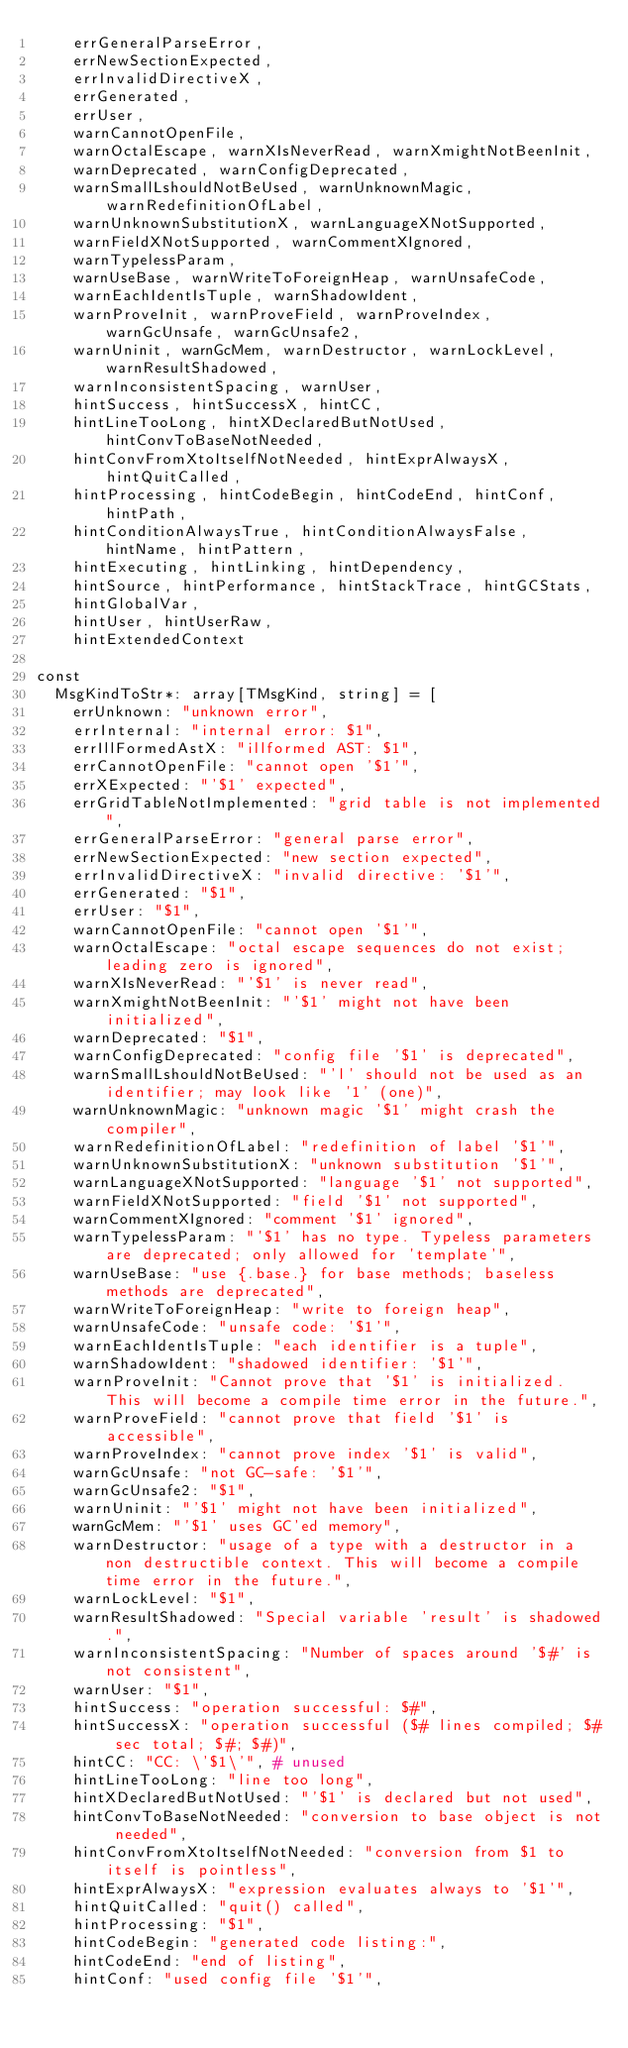Convert code to text. <code><loc_0><loc_0><loc_500><loc_500><_Nim_>    errGeneralParseError,
    errNewSectionExpected,
    errInvalidDirectiveX,
    errGenerated,
    errUser,
    warnCannotOpenFile,
    warnOctalEscape, warnXIsNeverRead, warnXmightNotBeenInit,
    warnDeprecated, warnConfigDeprecated,
    warnSmallLshouldNotBeUsed, warnUnknownMagic, warnRedefinitionOfLabel,
    warnUnknownSubstitutionX, warnLanguageXNotSupported,
    warnFieldXNotSupported, warnCommentXIgnored,
    warnTypelessParam,
    warnUseBase, warnWriteToForeignHeap, warnUnsafeCode,
    warnEachIdentIsTuple, warnShadowIdent,
    warnProveInit, warnProveField, warnProveIndex, warnGcUnsafe, warnGcUnsafe2,
    warnUninit, warnGcMem, warnDestructor, warnLockLevel, warnResultShadowed,
    warnInconsistentSpacing, warnUser,
    hintSuccess, hintSuccessX, hintCC,
    hintLineTooLong, hintXDeclaredButNotUsed, hintConvToBaseNotNeeded,
    hintConvFromXtoItselfNotNeeded, hintExprAlwaysX, hintQuitCalled,
    hintProcessing, hintCodeBegin, hintCodeEnd, hintConf, hintPath,
    hintConditionAlwaysTrue, hintConditionAlwaysFalse, hintName, hintPattern,
    hintExecuting, hintLinking, hintDependency,
    hintSource, hintPerformance, hintStackTrace, hintGCStats,
    hintGlobalVar,
    hintUser, hintUserRaw,
    hintExtendedContext

const
  MsgKindToStr*: array[TMsgKind, string] = [
    errUnknown: "unknown error",
    errInternal: "internal error: $1",
    errIllFormedAstX: "illformed AST: $1",
    errCannotOpenFile: "cannot open '$1'",
    errXExpected: "'$1' expected",
    errGridTableNotImplemented: "grid table is not implemented",
    errGeneralParseError: "general parse error",
    errNewSectionExpected: "new section expected",
    errInvalidDirectiveX: "invalid directive: '$1'",
    errGenerated: "$1",
    errUser: "$1",
    warnCannotOpenFile: "cannot open '$1'",
    warnOctalEscape: "octal escape sequences do not exist; leading zero is ignored",
    warnXIsNeverRead: "'$1' is never read",
    warnXmightNotBeenInit: "'$1' might not have been initialized",
    warnDeprecated: "$1",
    warnConfigDeprecated: "config file '$1' is deprecated",
    warnSmallLshouldNotBeUsed: "'l' should not be used as an identifier; may look like '1' (one)",
    warnUnknownMagic: "unknown magic '$1' might crash the compiler",
    warnRedefinitionOfLabel: "redefinition of label '$1'",
    warnUnknownSubstitutionX: "unknown substitution '$1'",
    warnLanguageXNotSupported: "language '$1' not supported",
    warnFieldXNotSupported: "field '$1' not supported",
    warnCommentXIgnored: "comment '$1' ignored",
    warnTypelessParam: "'$1' has no type. Typeless parameters are deprecated; only allowed for 'template'",
    warnUseBase: "use {.base.} for base methods; baseless methods are deprecated",
    warnWriteToForeignHeap: "write to foreign heap",
    warnUnsafeCode: "unsafe code: '$1'",
    warnEachIdentIsTuple: "each identifier is a tuple",
    warnShadowIdent: "shadowed identifier: '$1'",
    warnProveInit: "Cannot prove that '$1' is initialized. This will become a compile time error in the future.",
    warnProveField: "cannot prove that field '$1' is accessible",
    warnProveIndex: "cannot prove index '$1' is valid",
    warnGcUnsafe: "not GC-safe: '$1'",
    warnGcUnsafe2: "$1",
    warnUninit: "'$1' might not have been initialized",
    warnGcMem: "'$1' uses GC'ed memory",
    warnDestructor: "usage of a type with a destructor in a non destructible context. This will become a compile time error in the future.",
    warnLockLevel: "$1",
    warnResultShadowed: "Special variable 'result' is shadowed.",
    warnInconsistentSpacing: "Number of spaces around '$#' is not consistent",
    warnUser: "$1",
    hintSuccess: "operation successful: $#",
    hintSuccessX: "operation successful ($# lines compiled; $# sec total; $#; $#)",
    hintCC: "CC: \'$1\'", # unused
    hintLineTooLong: "line too long",
    hintXDeclaredButNotUsed: "'$1' is declared but not used",
    hintConvToBaseNotNeeded: "conversion to base object is not needed",
    hintConvFromXtoItselfNotNeeded: "conversion from $1 to itself is pointless",
    hintExprAlwaysX: "expression evaluates always to '$1'",
    hintQuitCalled: "quit() called",
    hintProcessing: "$1",
    hintCodeBegin: "generated code listing:",
    hintCodeEnd: "end of listing",
    hintConf: "used config file '$1'",</code> 